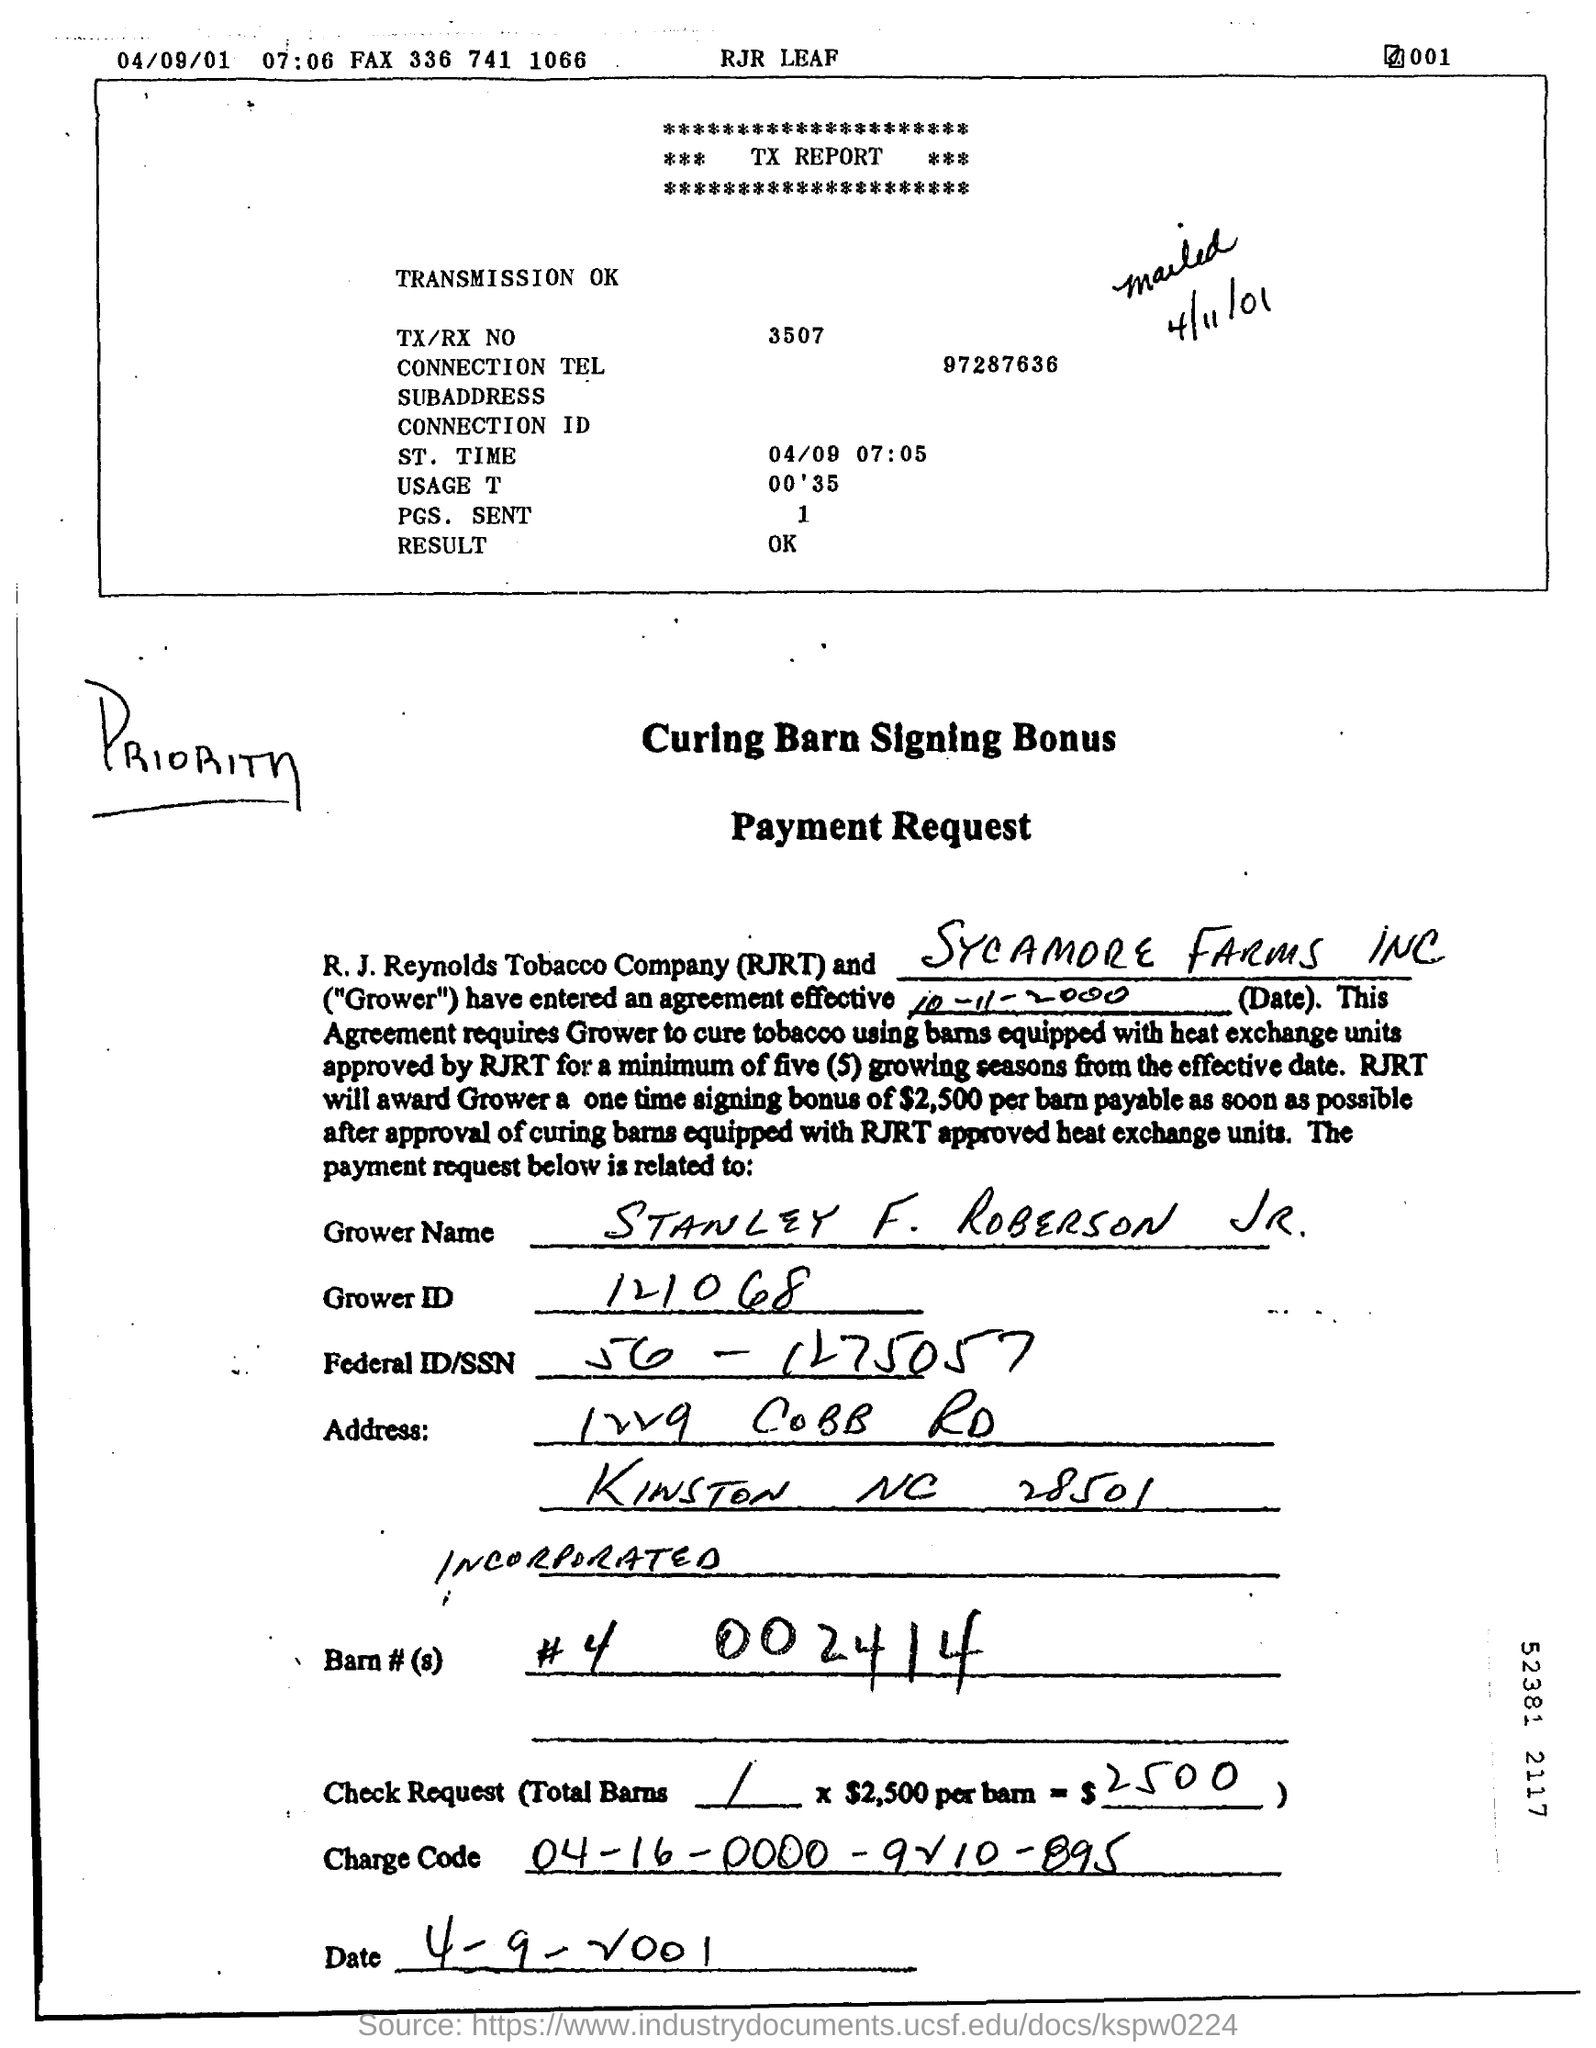What is grower name?
Keep it short and to the point. STANLEY F. ROBERSON JR. What is grower id?
Give a very brief answer. 121068. What is charge code?
Your answer should be very brief. 04-16-0000-9210-895. What is TX/RX NO mentioned in TX report?
Provide a short and direct response. 3507. What is the one time signing bonus that RJRT would award the Grower?
Give a very brief answer. $2,500 per barn. 